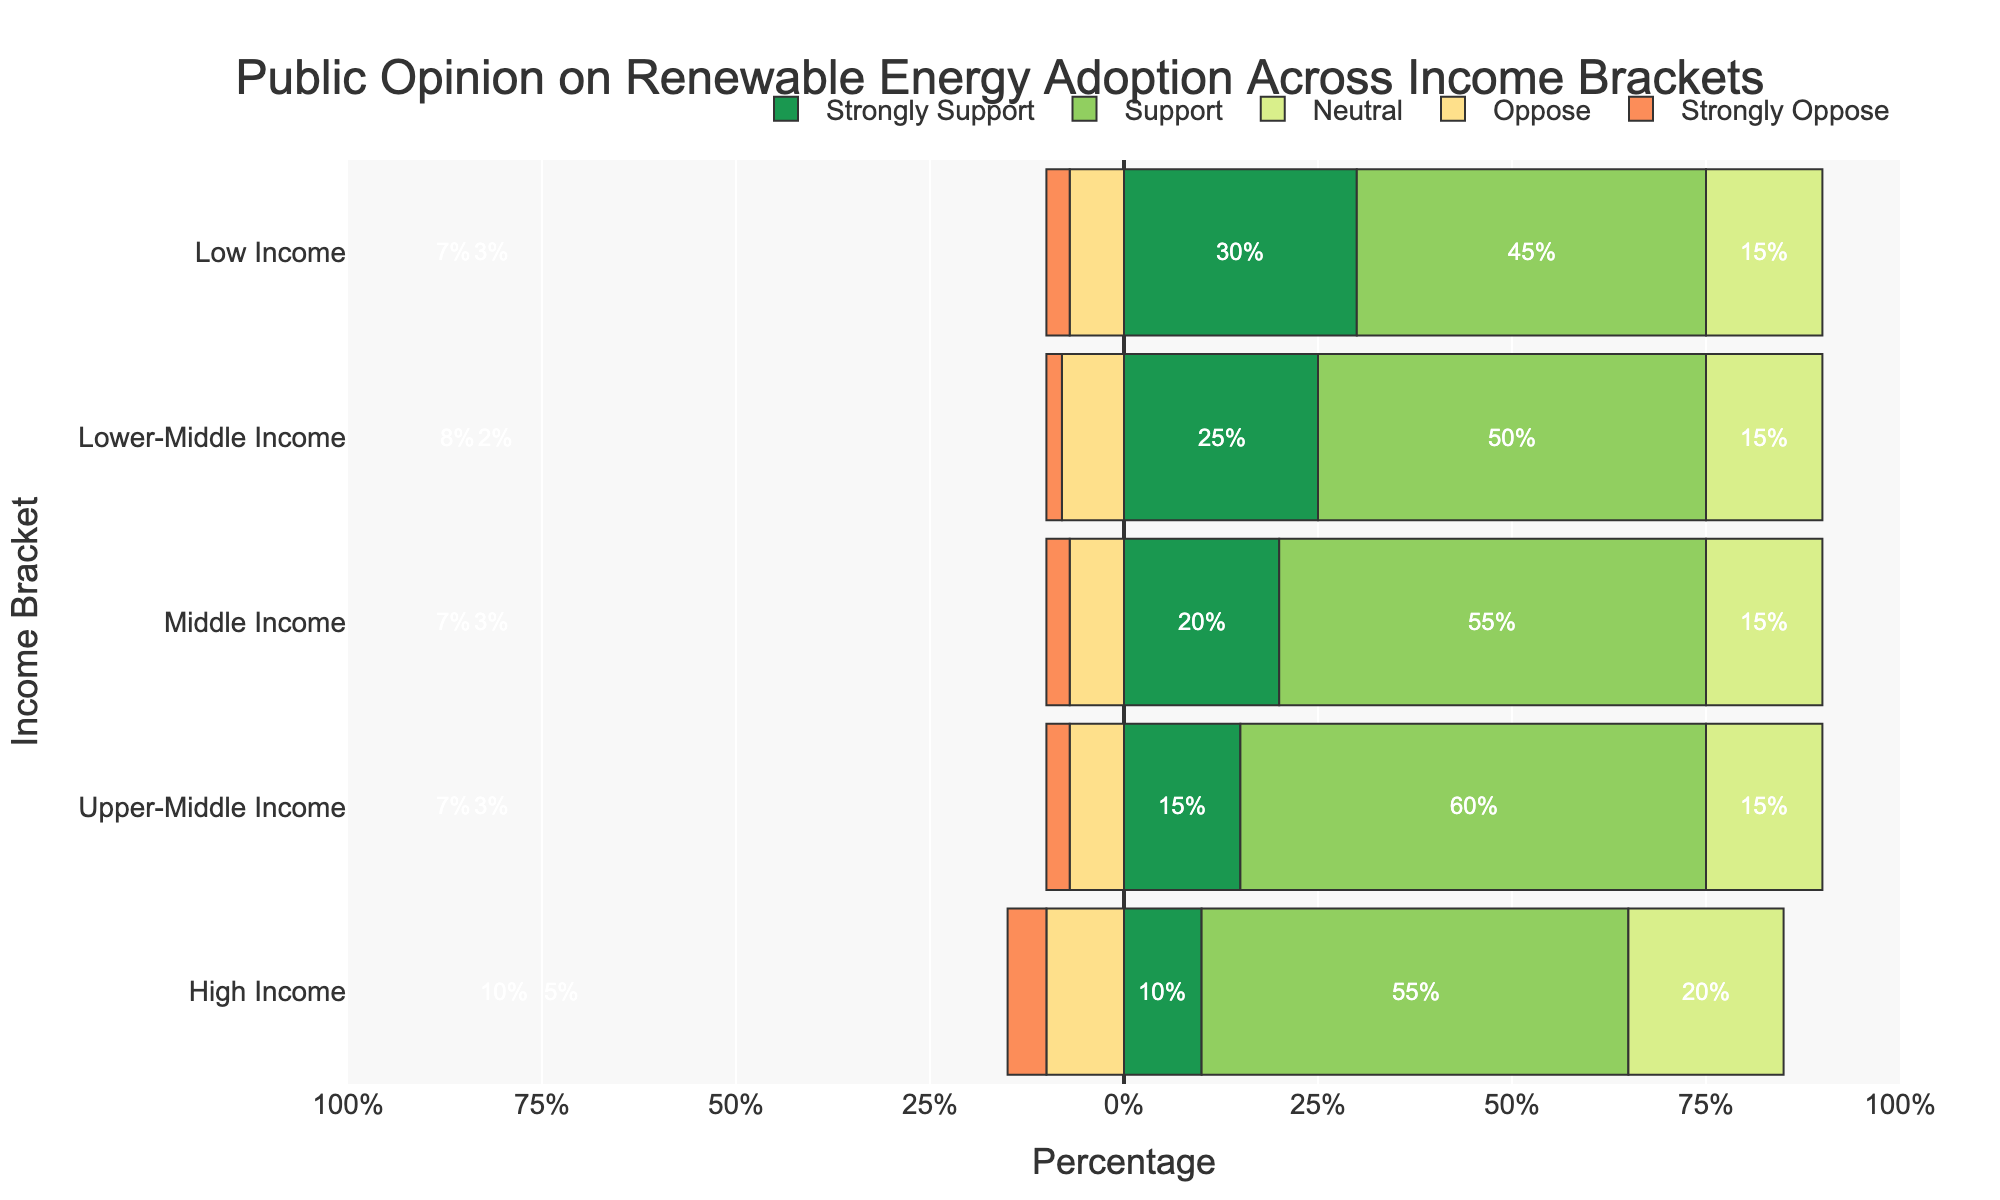What is the percentage of respondents in the High Income bracket who oppose or strongly oppose renewable energy adoption? Sum the percentages for "Oppose" and "Strongly Oppose" in the High Income bracket: 10% (Oppose) + 5% (Strongly Oppose) = 15%.
Answer: 15% How does the level of strong support for renewable energy in the Low Income bracket compare with the Middle Income bracket? Compare the percentage of "Strongly Support" between the Low Income bracket (30%) and the Middle Income bracket (20%). Since 30% > 20%, the Low Income bracket has a higher percentage of strong support.
Answer: Low Income has a higher percentage Which income bracket has the highest level of neutrality (Neutral) regarding renewable energy adoption? Identify the bar with the highest percentage in the "Neutral" category. Both Low Income, Lower-Middle Income, Middle Income, and Upper-Middle Income brackets have 15%, whereas High Income has 20%.
Answer: High Income What is the total support (Strongly Support + Support) for renewable energy in the Lower-Middle Income bracket? Sum the percentages of "Strongly Support" and "Support" in the Lower-Middle Income bracket: 25% (Strongly Support) + 50% (Support) = 75%.
Answer: 75% Which income bracket has the least opposition (Oppose + Strongly Oppose) to renewable energy? Sum the percentages of "Oppose" and "Strongly Oppose" for each income bracket: Low Income (7% + 3% = 10%), Lower-Middle Income (8% + 2% = 10%), Middle Income (7% + 3% = 10%), Upper-Middle Income (7% + 3% = 10%), High Income (10% + 5% = 15%). Since 10% < 15%, the Low, Lower-Middle, Middle, and Upper-Middle Income brackets have the least opposition with equal percentage.
Answer: Low, Lower-Middle, Middle, and Upper-Middle Income Compare the support (Support) levels for renewable energy between the Middle Income and Upper-Middle Income brackets. Compare the support levels: Middle Income (55%) vs. Upper-Middle Income (60%). Since 55% < 60%, the Upper-Middle Income bracket has higher support.
Answer: Upper-Middle Income has higher support What is the difference in strong opposition (Strongly Oppose) to renewable energy between the highest and lowest income brackets? Subtract the percentage of "Strongly Oppose" in the Low Income bracket (3%) from the High Income bracket (5%): 5% - 3% = 2%.
Answer: 2% Which category (Strongly Support, Support, Neutral, Oppose, Strongly Oppose) has the widest range of percentages across income brackets? Identify the category with the widest percentage range: Strongly Support (10%-30%), Support (45%-60%), Neutral (15%-20%), Oppose (7%-10%), Strongly Oppose (2%-5%). The widest range is in "Strongly Support" (20%).
Answer: Strongly Support How does the overall opposition (Neutral + Oppose + Strongly Oppose) in the Upper-Middle Income bracket compare to the Middle Income bracket? Sum the percentages for Neutral, Oppose, and Strongly Oppose in the Upper-Middle Income (15% + 7% + 3% = 25%) and Middle Income (15% + 7% + 3% = 25%) brackets. Both total to 25%.
Answer: They are equal 